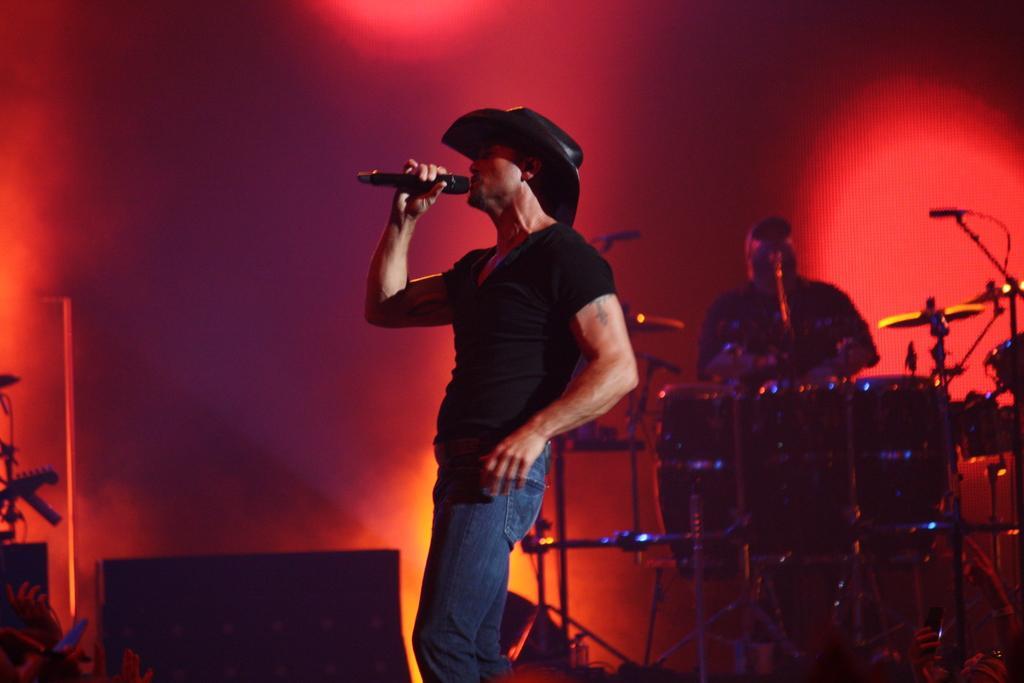Can you describe this image briefly? In the image we can see there is a man who is standing and he is holding mic in his hand and at the back there is another man who is playing drums. 